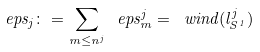Convert formula to latex. <formula><loc_0><loc_0><loc_500><loc_500>\ e p s _ { j } \colon = \sum _ { m \leq n ^ { j } } \ e p s ^ { j } _ { m } = \ w i n d ( l _ { S ^ { 1 } } ^ { j } )</formula> 